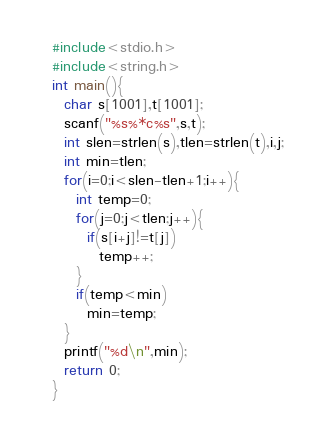<code> <loc_0><loc_0><loc_500><loc_500><_C_>#include<stdio.h>
#include<string.h>
int main(){
  char s[1001],t[1001];
  scanf("%s%*c%s",s,t);
  int slen=strlen(s),tlen=strlen(t),i,j;
  int min=tlen;
  for(i=0;i<slen-tlen+1;i++){
    int temp=0;
    for(j=0;j<tlen;j++){
      if(s[i+j]!=t[j])
        temp++;
    }
    if(temp<min)
      min=temp;
  }
  printf("%d\n",min);
  return 0;
}
</code> 